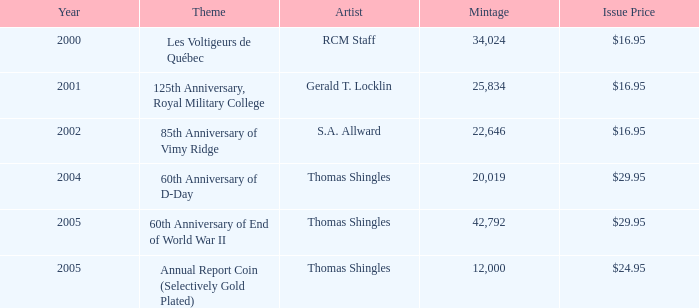What was the total mintage for years after 2002 that had a 85th Anniversary of Vimy Ridge theme? 0.0. 